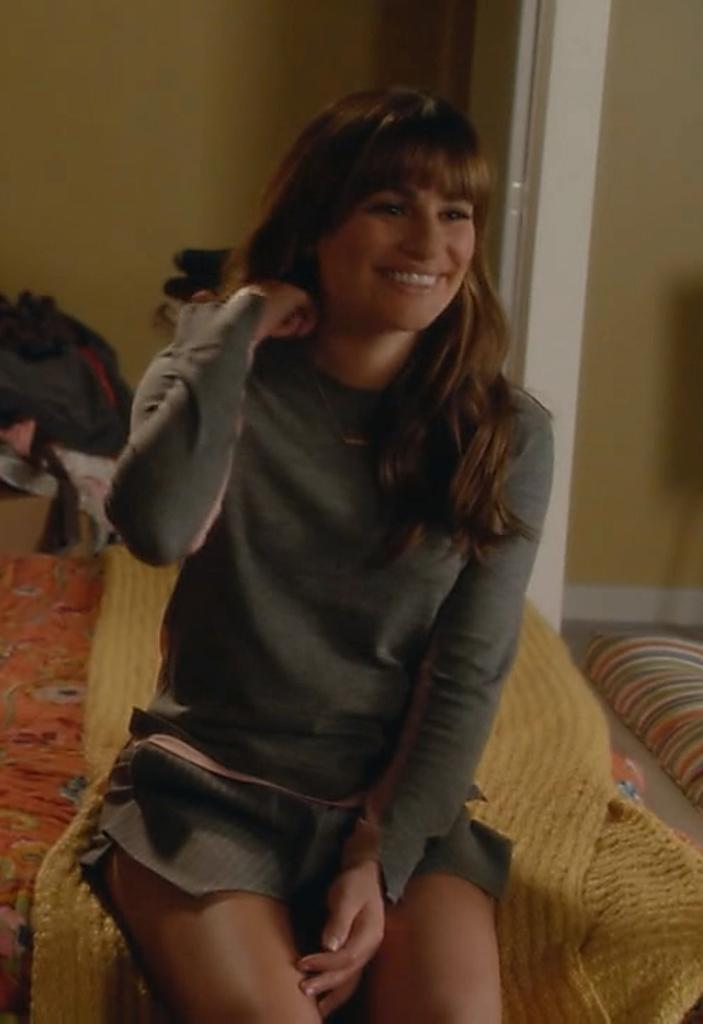Who is present in the image? There is a woman in the image. What is the woman wearing? The woman is wearing a skirt. What is the woman's facial expression? The woman is smiling. Where is the woman sitting? The woman is sitting on a bed. What is covering the bed? The bed is covered with a bed sheet. What can be seen in the background of the image? There is a wall in the background of the image. What type of muscle can be seen flexing in the image? There is no muscle visible in the image; it features a woman sitting on a bed. What industry is depicted in the image? There is no industry present in the image; it features a woman sitting on a bed. 